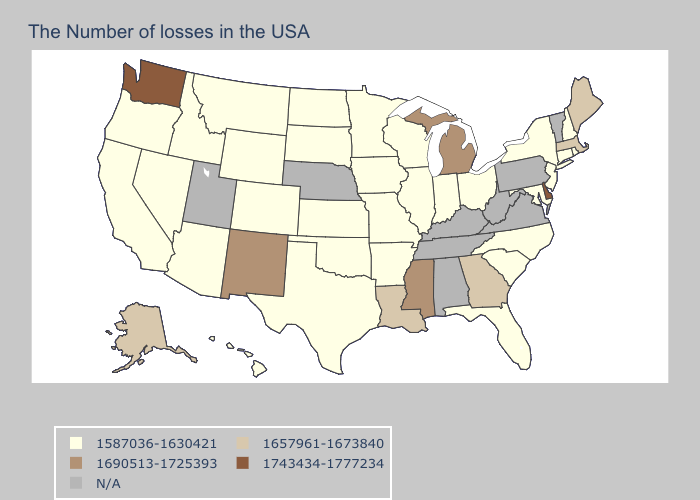Does Colorado have the highest value in the USA?
Concise answer only. No. Which states have the lowest value in the USA?
Short answer required. Rhode Island, New Hampshire, Connecticut, New York, New Jersey, Maryland, North Carolina, South Carolina, Ohio, Florida, Indiana, Wisconsin, Illinois, Missouri, Arkansas, Minnesota, Iowa, Kansas, Oklahoma, Texas, South Dakota, North Dakota, Wyoming, Colorado, Montana, Arizona, Idaho, Nevada, California, Oregon, Hawaii. What is the highest value in the USA?
Give a very brief answer. 1743434-1777234. What is the lowest value in states that border West Virginia?
Short answer required. 1587036-1630421. Among the states that border Arizona , does California have the lowest value?
Short answer required. Yes. Name the states that have a value in the range 1587036-1630421?
Short answer required. Rhode Island, New Hampshire, Connecticut, New York, New Jersey, Maryland, North Carolina, South Carolina, Ohio, Florida, Indiana, Wisconsin, Illinois, Missouri, Arkansas, Minnesota, Iowa, Kansas, Oklahoma, Texas, South Dakota, North Dakota, Wyoming, Colorado, Montana, Arizona, Idaho, Nevada, California, Oregon, Hawaii. Which states have the lowest value in the USA?
Write a very short answer. Rhode Island, New Hampshire, Connecticut, New York, New Jersey, Maryland, North Carolina, South Carolina, Ohio, Florida, Indiana, Wisconsin, Illinois, Missouri, Arkansas, Minnesota, Iowa, Kansas, Oklahoma, Texas, South Dakota, North Dakota, Wyoming, Colorado, Montana, Arizona, Idaho, Nevada, California, Oregon, Hawaii. Among the states that border Massachusetts , which have the lowest value?
Short answer required. Rhode Island, New Hampshire, Connecticut, New York. Does Wisconsin have the highest value in the USA?
Answer briefly. No. Does North Dakota have the lowest value in the USA?
Quick response, please. Yes. How many symbols are there in the legend?
Give a very brief answer. 5. Among the states that border New Mexico , which have the lowest value?
Answer briefly. Oklahoma, Texas, Colorado, Arizona. What is the value of Maryland?
Keep it brief. 1587036-1630421. What is the value of Arkansas?
Answer briefly. 1587036-1630421. Which states hav the highest value in the South?
Answer briefly. Delaware. 